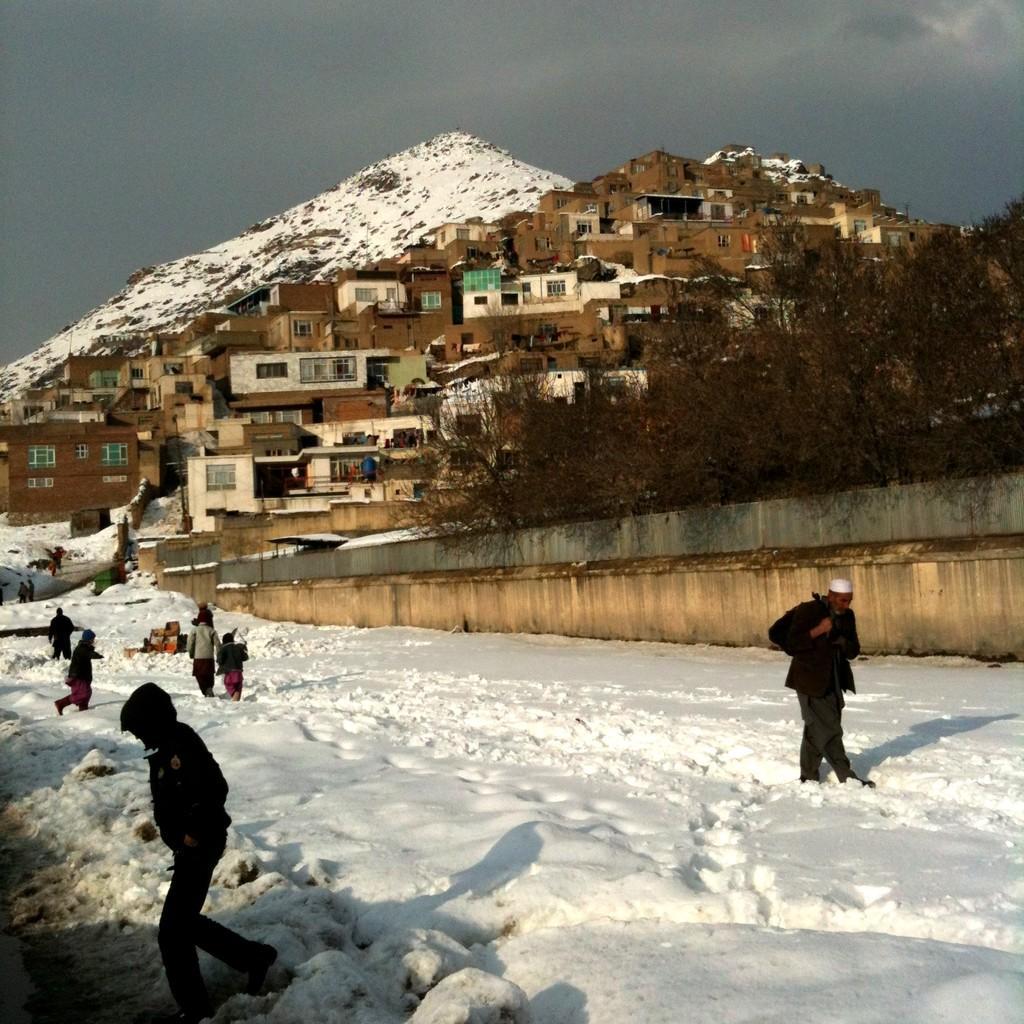In one or two sentences, can you explain what this image depicts? In this picture I can see snow. There are group of people standing. I can see buildings, trees and a snowy mountain, and in the background there is the sky. 